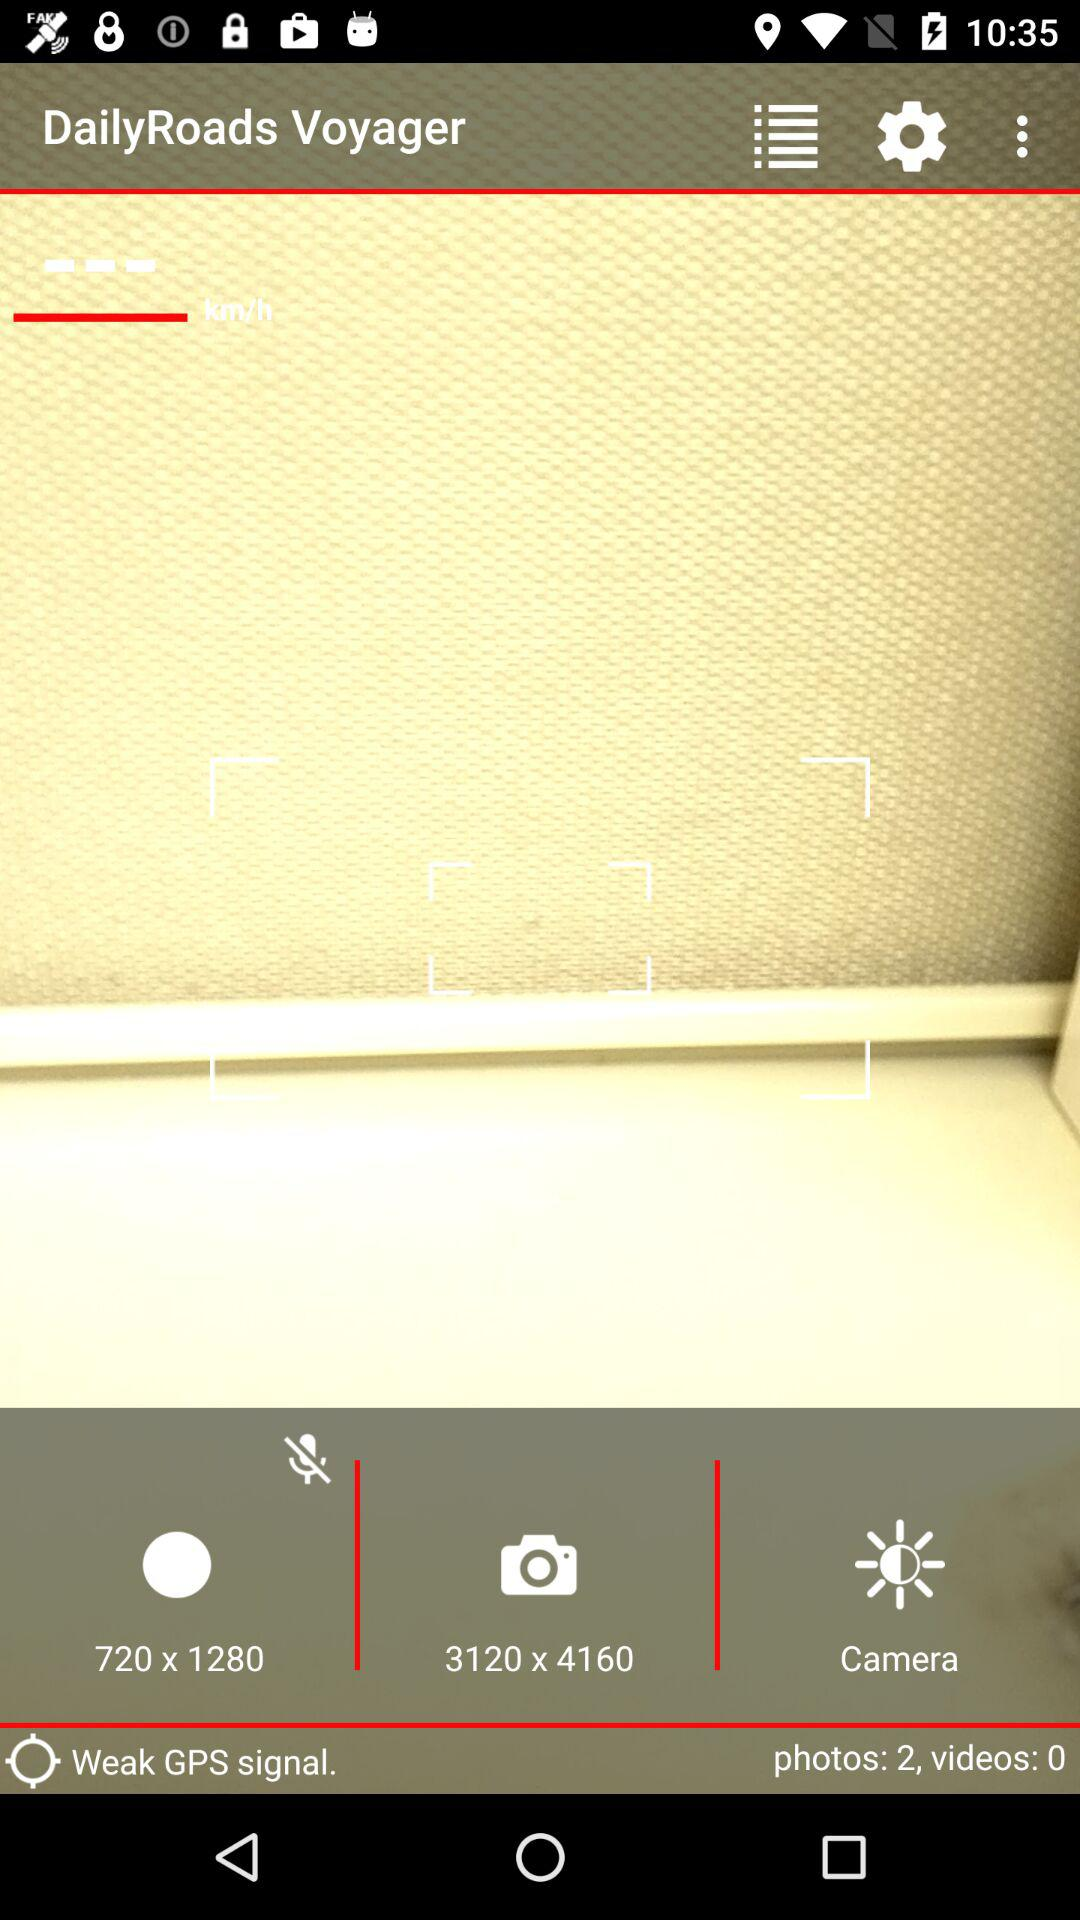How many photos and videos are available? There are 2 photos and 0 videos. 